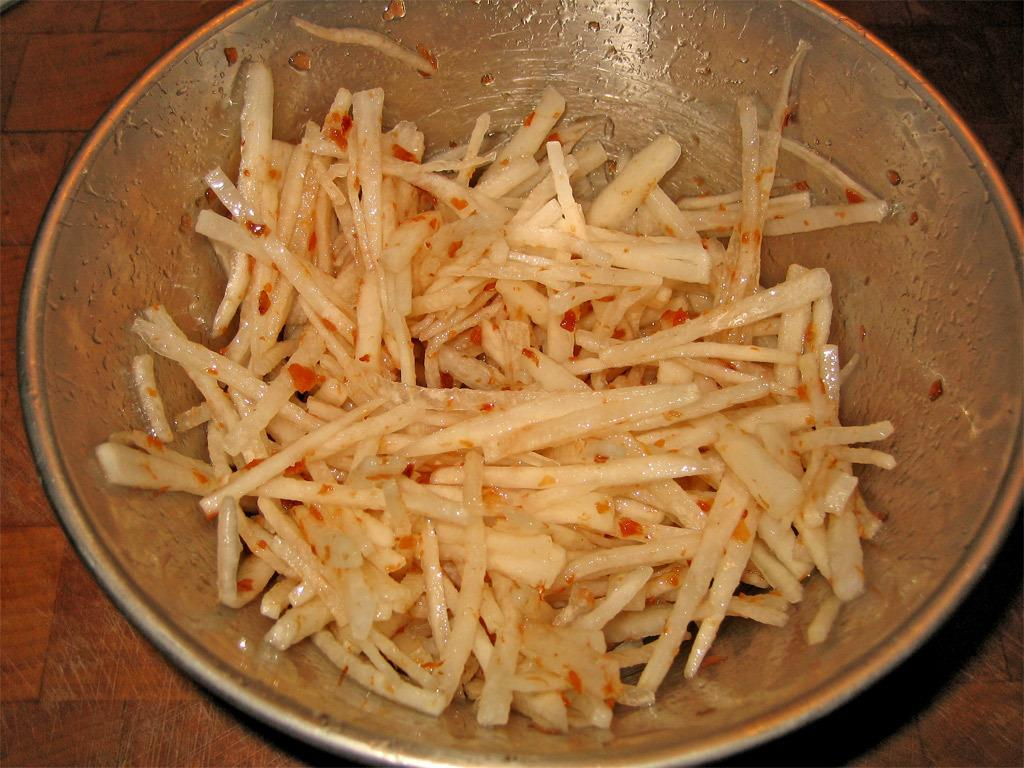What is in the bowl that is visible in the image? There is food in a bowl in the image. Where is the bowl located in the image? The bowl is placed on a wooden platform. What type of discussion is taking place in the image? There is no discussion taking place in the image; it only shows a bowl of food on a wooden platform. 